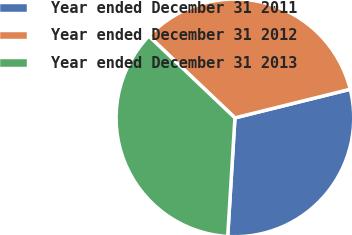Convert chart. <chart><loc_0><loc_0><loc_500><loc_500><pie_chart><fcel>Year ended December 31 2011<fcel>Year ended December 31 2012<fcel>Year ended December 31 2013<nl><fcel>29.84%<fcel>34.03%<fcel>36.12%<nl></chart> 